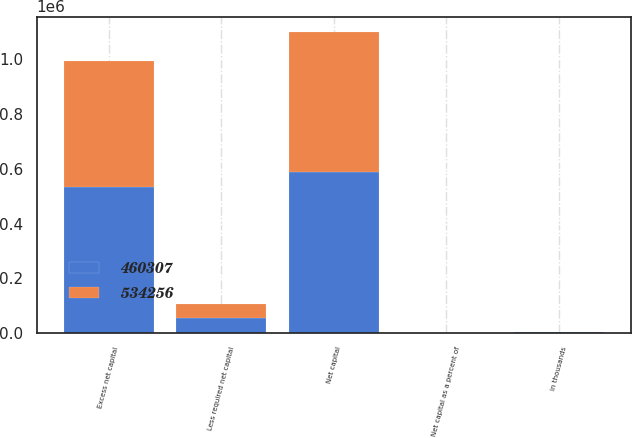Convert chart. <chart><loc_0><loc_0><loc_500><loc_500><stacked_bar_chart><ecel><fcel>in thousands<fcel>Net capital as a percent of<fcel>Net capital<fcel>Less required net capital<fcel>Excess net capital<nl><fcel>460307<fcel>2017<fcel>21.37<fcel>589420<fcel>55164<fcel>534256<nl><fcel>534256<fcel>2016<fcel>19.61<fcel>512594<fcel>52287<fcel>460307<nl></chart> 